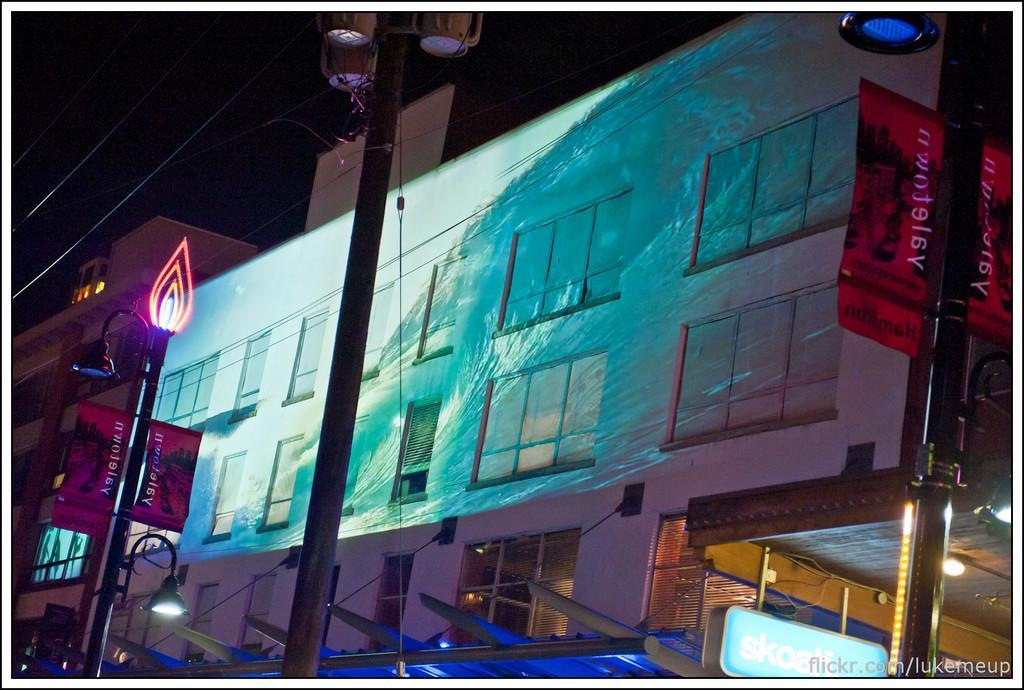Please provide a concise description of this image. In this picture there is a small building with some window glasses. In the front we can see the black color lamp post and cable. 